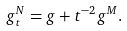<formula> <loc_0><loc_0><loc_500><loc_500>g _ { t } ^ { N } = g + t ^ { - 2 } g ^ { M } .</formula> 